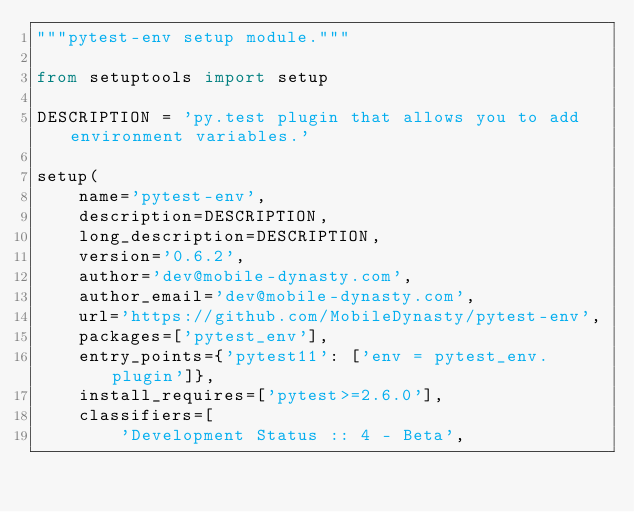<code> <loc_0><loc_0><loc_500><loc_500><_Python_>"""pytest-env setup module."""

from setuptools import setup

DESCRIPTION = 'py.test plugin that allows you to add environment variables.'

setup(
    name='pytest-env',
    description=DESCRIPTION,
    long_description=DESCRIPTION,
    version='0.6.2',
    author='dev@mobile-dynasty.com',
    author_email='dev@mobile-dynasty.com',
    url='https://github.com/MobileDynasty/pytest-env',
    packages=['pytest_env'],
    entry_points={'pytest11': ['env = pytest_env.plugin']},
    install_requires=['pytest>=2.6.0'],
    classifiers=[
        'Development Status :: 4 - Beta',</code> 